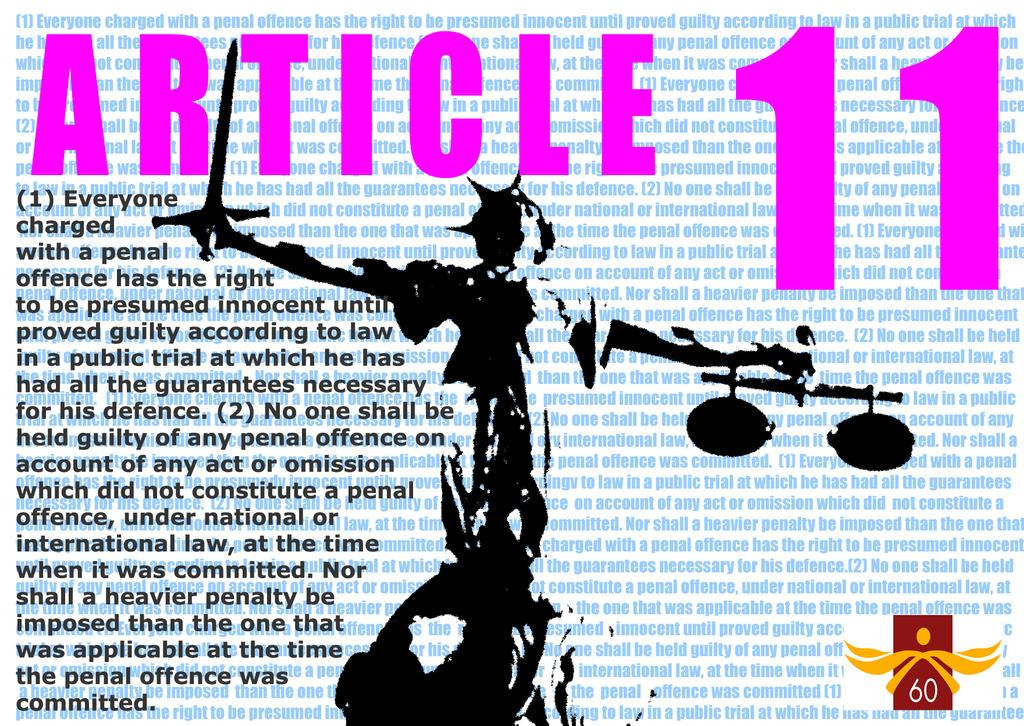<image>
Share a concise interpretation of the image provided. A poster of Lady Justice titled Article 11 and a wall of text. 